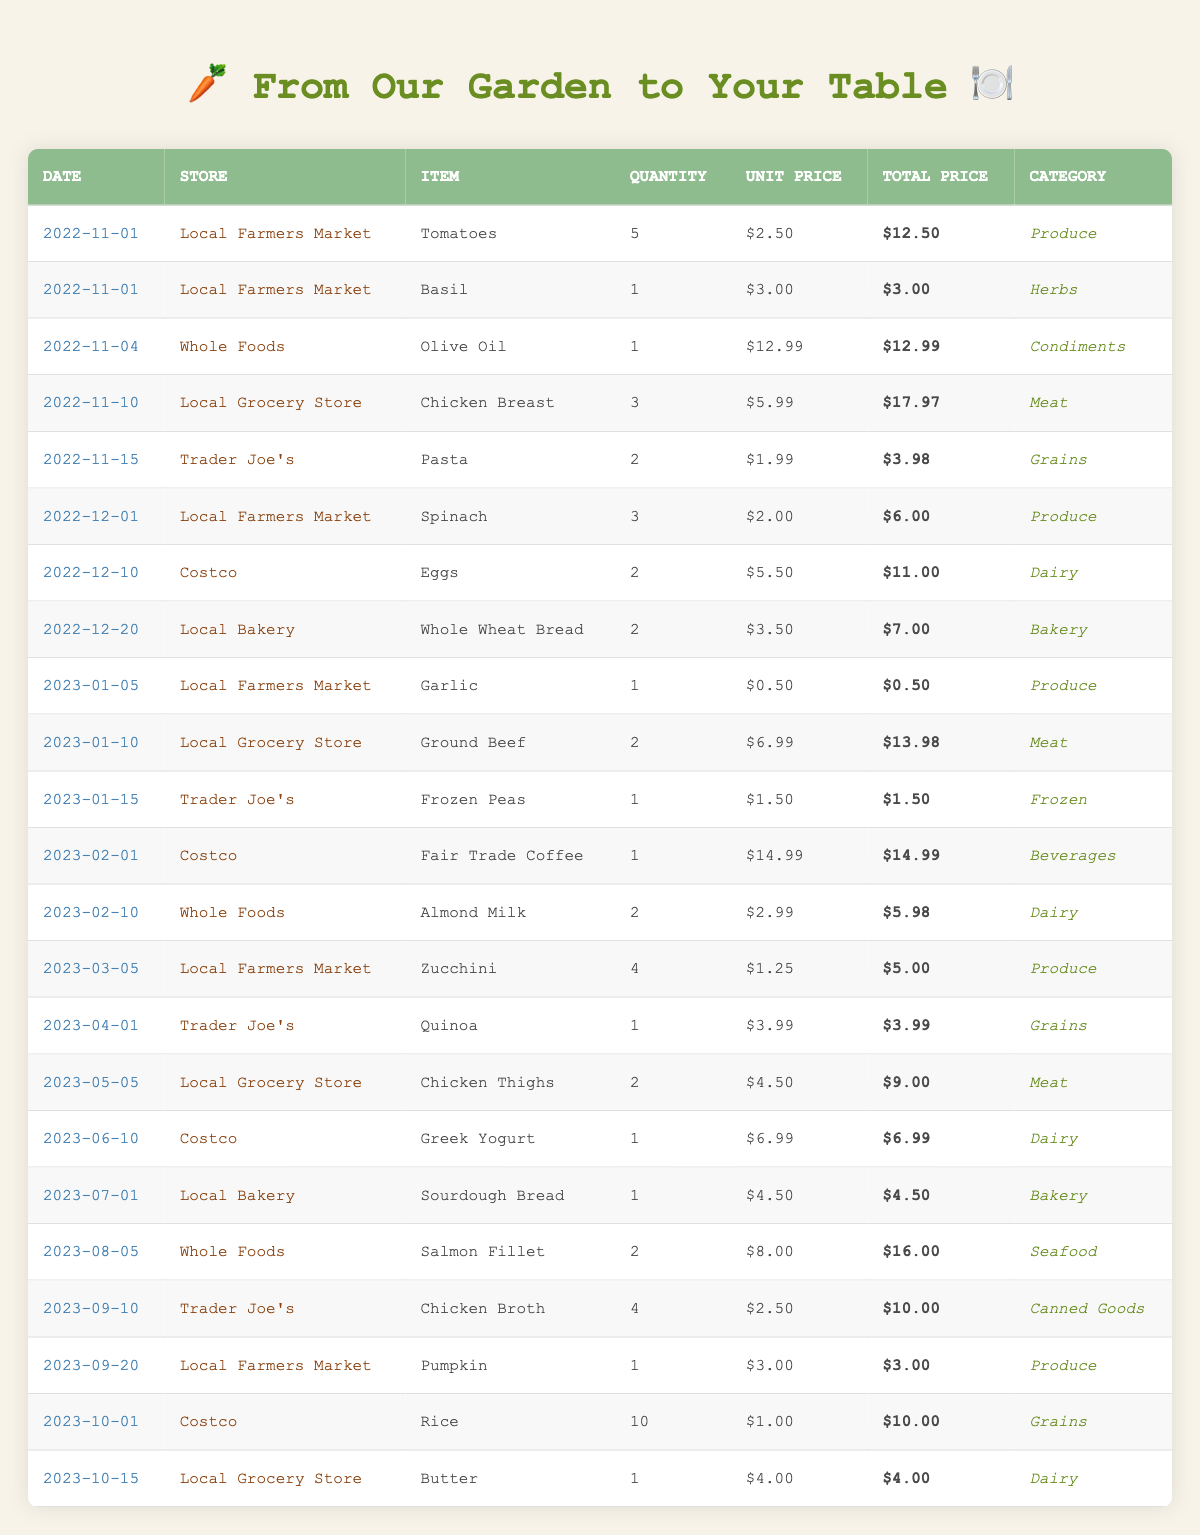What was the total amount spent on dairy products? To find the total expense for dairy products, we check the table for items in the "Dairy" category: Eggs ($11.00), Almond Milk ($5.98), Greek Yogurt ($6.99), Butter ($4.00). Adding them together gives us $11.00 + $5.98 + $6.99 + $4.00 = $27.97.
Answer: $27.97 Which item was purchased the most frequently throughout the year? We need to examine the quantity of each item purchased. The highest quantity found in the table is Rice (10), followed by items like Chicken Breast (3) and Chicken Broth (4). Therefore, Rice is the most frequently purchased item.
Answer: Rice How much did the Local Farmers Market earn in total? We look for all purchases made at the Local Farmers Market and sum their total prices: Tomatoes ($12.50), Basil ($3.00), Spinach ($6.00), Garlic ($0.50), Zucchini ($5.00), Pumpkin ($3.00). Adding these up gives $12.50 + $3.00 + $6.00 + $0.50 + $5.00 + $3.00 = $30.00.
Answer: $30.00 Was the total spending on grains higher than that on produce? First, we calculate total spending on grains, which consists of Pasta ($3.98), Quinoa ($3.99), and Rice ($10.00), totaling $3.98 + $3.99 + $10.00 = $17.97. Next, we calculate total spending on produce: Tomatoes ($12.50), Spinach ($6.00), Garlic ($0.50), Zucchini ($5.00), and Pumpkin ($3.00), totaling $12.50 + $6.00 + $0.50 + $5.00 + $3.00 = $27.00. Finally, we compare $17.97 to $27.00; since $17.97 is less than $27.00, grains spending is not higher.
Answer: No How many unique types of stores did I shop at? Counting each listed store in the table: Local Farmers Market, Whole Foods, Local Grocery Store, Trader Joe's, Costco, Local Bakery, and Local Bakery. We find that there are 6 unique stores: Local Farmers Market, Whole Foods, Local Grocery Store, Trader Joe's, Costco, and Local Bakery.
Answer: 6 What was the average spending per shopping trip? There are 25 entries in the table; we sum the total prices of all purchases (which equals $214.92) and then divide by the number of entries: $214.92 / 25 = $8.60.
Answer: $8.60 Did I buy any items in the 'Seafood' category? Checking the table, there is one entry for Seafood: Salmon Fillet ($16.00). Since this entry exists, the answer is yes.
Answer: Yes What was the highest amount spent on a single item, and which item was it? We look through the total prices and find that the highest amount is Fair Trade Coffee at $14.99.
Answer: Fair Trade Coffee at $14.99 How much did I spend on herbs compared to canned goods? For herbs: Basil ($3.00); and for canned goods: Chicken Broth ($10.00). Comparing $3.00 with $10.00, it's clear canned goods spending is higher than herbs.
Answer: Canned goods are higher What is the total amount spent in September? The items purchased in September include Chicken Broth ($10.00) and Pumpkin ($3.00), so the total for September is $10.00 + $3.00 = $13.00.
Answer: $13.00 Which month had the highest grocery spending? We calculate monthly totals: November (15.47), December (25.00), January (16.48), February (20.97), March (5.00), April (3.99), May (9.00), June (6.99), July (4.50), August (16.00), September (13.00), and October (14.00). December's total is the highest.
Answer: December 